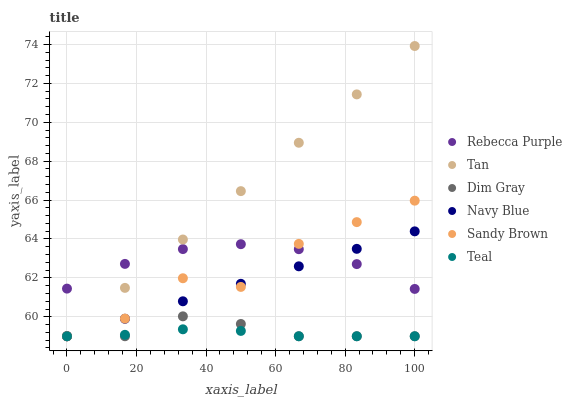Does Teal have the minimum area under the curve?
Answer yes or no. Yes. Does Tan have the maximum area under the curve?
Answer yes or no. Yes. Does Navy Blue have the minimum area under the curve?
Answer yes or no. No. Does Navy Blue have the maximum area under the curve?
Answer yes or no. No. Is Tan the smoothest?
Answer yes or no. Yes. Is Sandy Brown the roughest?
Answer yes or no. Yes. Is Navy Blue the smoothest?
Answer yes or no. No. Is Navy Blue the roughest?
Answer yes or no. No. Does Dim Gray have the lowest value?
Answer yes or no. Yes. Does Rebecca Purple have the lowest value?
Answer yes or no. No. Does Tan have the highest value?
Answer yes or no. Yes. Does Navy Blue have the highest value?
Answer yes or no. No. Is Teal less than Rebecca Purple?
Answer yes or no. Yes. Is Rebecca Purple greater than Teal?
Answer yes or no. Yes. Does Teal intersect Dim Gray?
Answer yes or no. Yes. Is Teal less than Dim Gray?
Answer yes or no. No. Is Teal greater than Dim Gray?
Answer yes or no. No. Does Teal intersect Rebecca Purple?
Answer yes or no. No. 